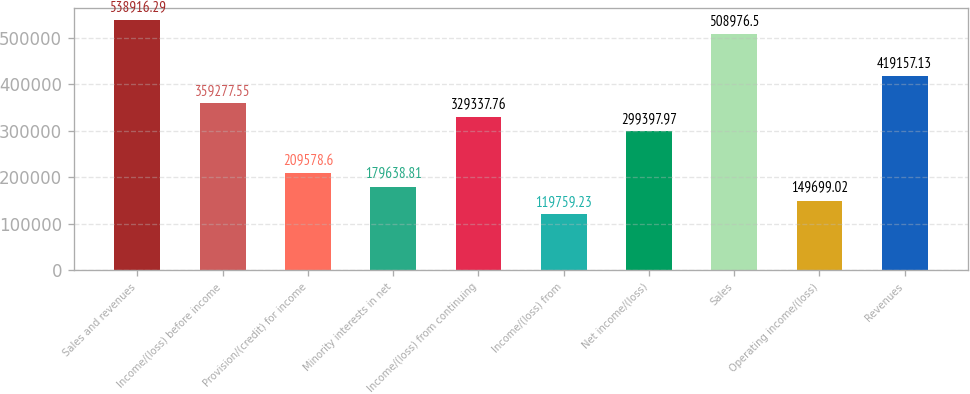<chart> <loc_0><loc_0><loc_500><loc_500><bar_chart><fcel>Sales and revenues<fcel>Income/(loss) before income<fcel>Provision/(credit) for income<fcel>Minority interests in net<fcel>Income/(loss) from continuing<fcel>Income/(loss) from<fcel>Net income/(loss)<fcel>Sales<fcel>Operating income/(loss)<fcel>Revenues<nl><fcel>538916<fcel>359278<fcel>209579<fcel>179639<fcel>329338<fcel>119759<fcel>299398<fcel>508976<fcel>149699<fcel>419157<nl></chart> 